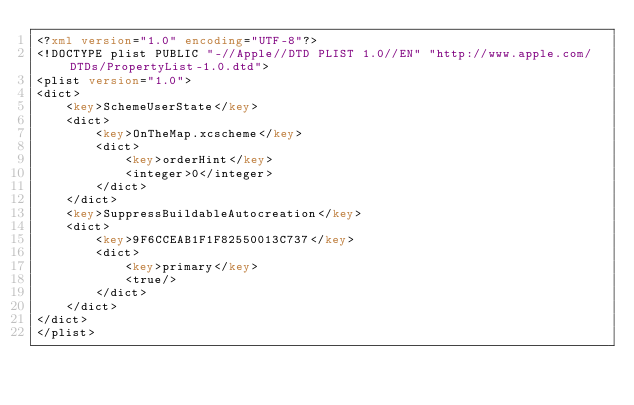Convert code to text. <code><loc_0><loc_0><loc_500><loc_500><_XML_><?xml version="1.0" encoding="UTF-8"?>
<!DOCTYPE plist PUBLIC "-//Apple//DTD PLIST 1.0//EN" "http://www.apple.com/DTDs/PropertyList-1.0.dtd">
<plist version="1.0">
<dict>
	<key>SchemeUserState</key>
	<dict>
		<key>OnTheMap.xcscheme</key>
		<dict>
			<key>orderHint</key>
			<integer>0</integer>
		</dict>
	</dict>
	<key>SuppressBuildableAutocreation</key>
	<dict>
		<key>9F6CCEAB1F1F82550013C737</key>
		<dict>
			<key>primary</key>
			<true/>
		</dict>
	</dict>
</dict>
</plist>
</code> 